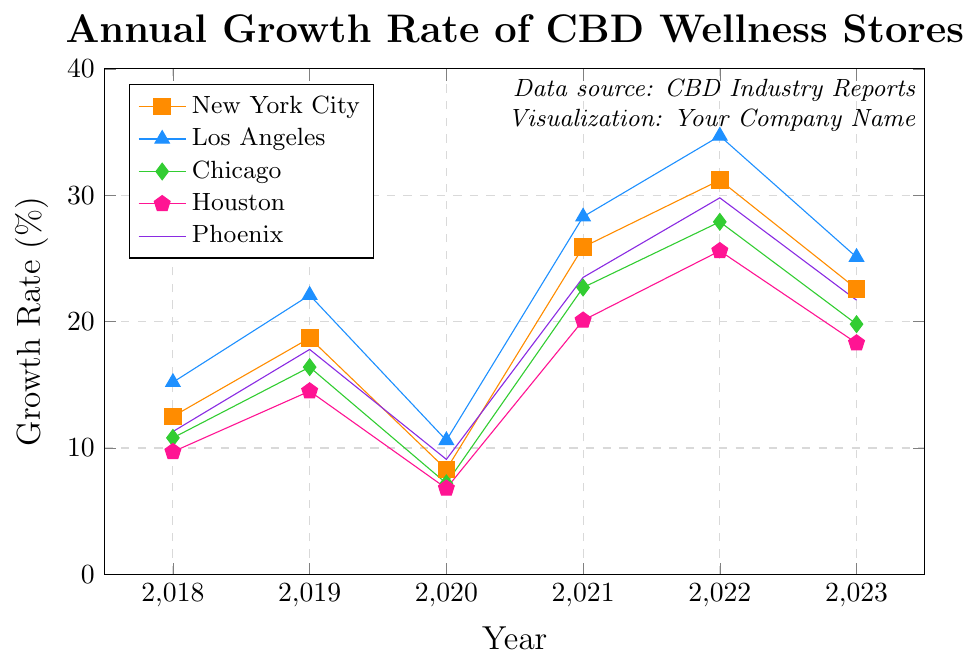What's the highest annual growth rate for Los Angeles? By looking at the plot, the highest growth rate for Los Angeles occurs in 2022. The value is marked and can be seen to be the highest point on Los Angeles's line graph.
Answer: 34.7% Which city had the lowest growth rate in 2020? By observing each line graph at the point corresponding to the year 2020, Houston has the lowest growth rate. The value for Houston at this point is 6.8%.
Answer: Houston Between New York City and Phoenix, which city had a higher growth rate in 2021? The growth rate for New York City in 2021 is 25.9% and for Phoenix, it is 23.5%. Comparing these two values, New York City has a higher growth rate in 2021.
Answer: New York City What's the average annual growth rate for Chicago over the given period? The growth rates for Chicago from 2018 to 2023 are 10.8%, 16.4%, 7.2%, 22.7%, 27.9%, and 19.8%. Summing these values gives 104.8% and dividing by 6 (the number of years) gives an average of approximately 17.47%.
Answer: 17.47% By how much did New York City's growth rate change from 2018 to 2022? The growth rate for New York City in 2018 is 12.5%, and in 2022 it is 31.2%. The change is calculated by subtracting the 2018 rate from the 2022 rate, which gives 31.2% - 12.5% = 18.7%.
Answer: 18.7% Which city showed the most consistent growth pattern between 2018 and 2023? Consistency in growth can be visually assessed by observing the smoothness and fewer fluctuations in the line graph. Los Angeles has a relatively smoother and more consistent increasing pattern compared to other cities that show more variations up and down.
Answer: Los Angeles How much did the growth rate of CBD wellness stores in Houston increase from 2020 to 2021? The growth rate for Houston in 2020 was 6.8% and in 2021 it was 20.1%. The increase is calculated by subtracting the 2020 rate from the 2021 rate, which gives 20.1% - 6.8% = 13.3%.
Answer: 13.3% What is the overall trend for CBD wellness stores' growth rates in the plotted cities from 2018 to 2023? By observing the general direction of the lines for each city, an overall increasing trend can be seen, although there are some fluctuations in certain years (like 2020 seeing a dip). Generally, the growth rates in 2023 are higher compared to 2018 for all cities.
Answer: Increasing trend Which city had the highest growth rate in 2023? By looking at the points on the plot for the year 2023, Los Angeles has the highest growth rate among the cities, which is 25.1%.
Answer: Los Angeles 